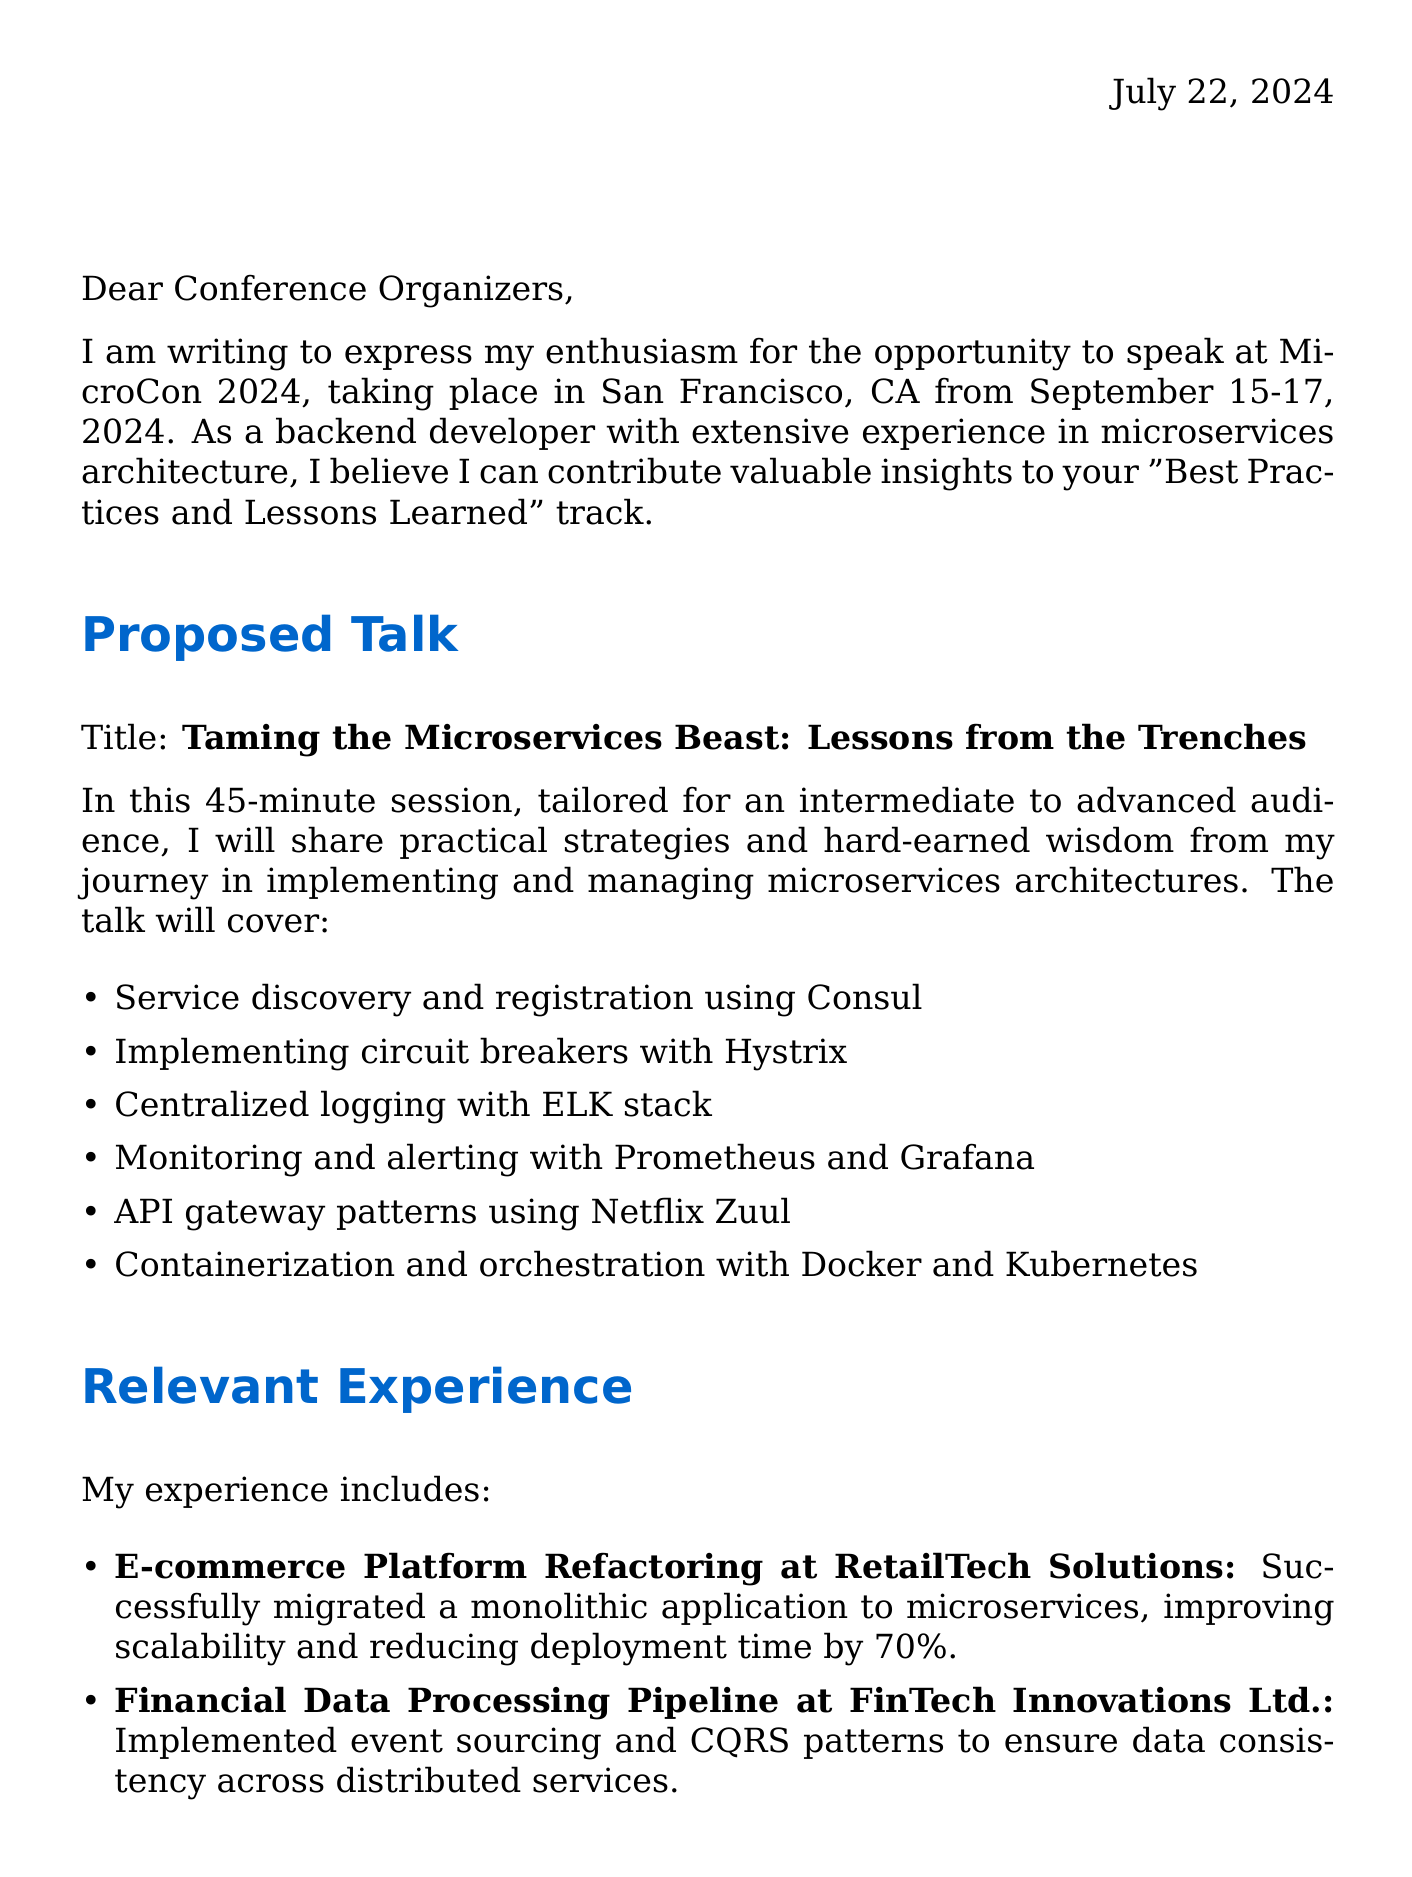What is the name of the conference? The name of the conference is stated in the document as "MicroCon 2024."
Answer: MicroCon 2024 What are the dates of the conference? The dates of the conference are mentioned in the document, specifically from September 15-17, 2024.
Answer: September 15-17, 2024 What is the proposed talk title? The proposed talk title is explicitly given as "Taming the Microservices Beast: Lessons from the Trenches."
Answer: Taming the Microservices Beast: Lessons from the Trenches What are two key topics covered in the talk? The document lists key topics including service discovery and registration using Consul and centralized logging with the ELK stack.
Answer: Service discovery and registration using Consul, centralized logging with ELK stack What is one potential takeaway from the session? The document outlines practical strategies for breaking down monoliths into microservices as one of the potential takeaways.
Answer: Breaking down monoliths into microservices What is the session duration? The session duration is specifically stated in the document as lasting for 45 minutes.
Answer: 45 minutes Who organized the conference? The organizer of the conference is mentioned in the document as "TechEvents Inc."
Answer: TechEvents Inc What is a benefit of being a speaker at the conference? One of the benefits listed in the document is gaining recognition as a thought leader in microservices architecture.
Answer: Gain recognition as a thought leader in microservices architecture What is the target audience level for the talk? The document specifies the audience level as "Intermediate to Advanced."
Answer: Intermediate to Advanced 